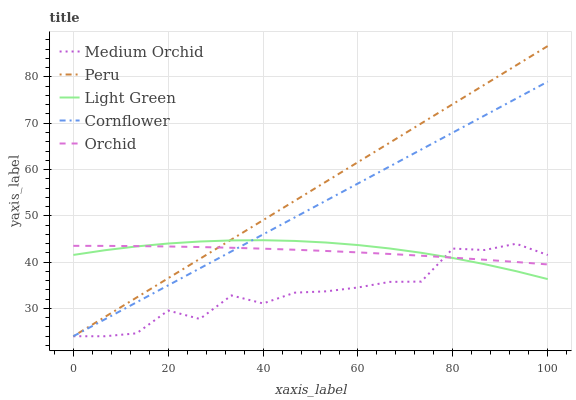Does Medium Orchid have the minimum area under the curve?
Answer yes or no. Yes. Does Peru have the maximum area under the curve?
Answer yes or no. Yes. Does Light Green have the minimum area under the curve?
Answer yes or no. No. Does Light Green have the maximum area under the curve?
Answer yes or no. No. Is Cornflower the smoothest?
Answer yes or no. Yes. Is Medium Orchid the roughest?
Answer yes or no. Yes. Is Light Green the smoothest?
Answer yes or no. No. Is Light Green the roughest?
Answer yes or no. No. Does Light Green have the lowest value?
Answer yes or no. No. Does Peru have the highest value?
Answer yes or no. Yes. Does Medium Orchid have the highest value?
Answer yes or no. No. Does Cornflower intersect Medium Orchid?
Answer yes or no. Yes. Is Cornflower less than Medium Orchid?
Answer yes or no. No. Is Cornflower greater than Medium Orchid?
Answer yes or no. No. 